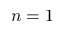Convert formula to latex. <formula><loc_0><loc_0><loc_500><loc_500>n = 1</formula> 